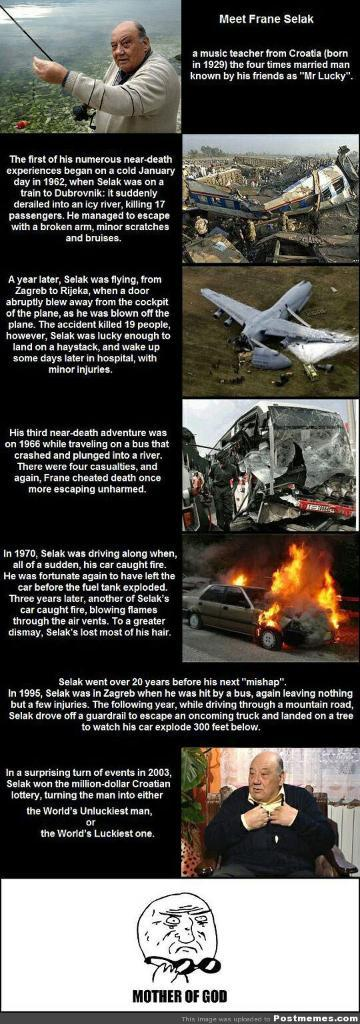<image>
Summarize the visual content of the image. a meme about a man called France Selak 